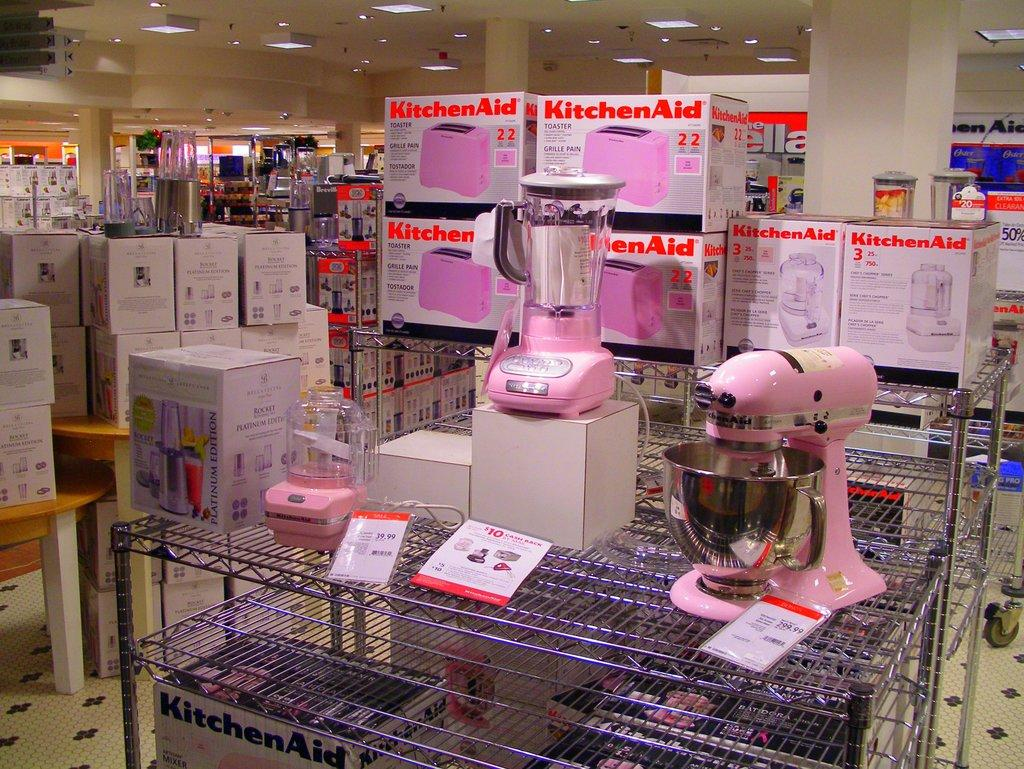Provide a one-sentence caption for the provided image. A stand of kitchen aid appliances including toasters and mixers are all pink and displayed in a store. 